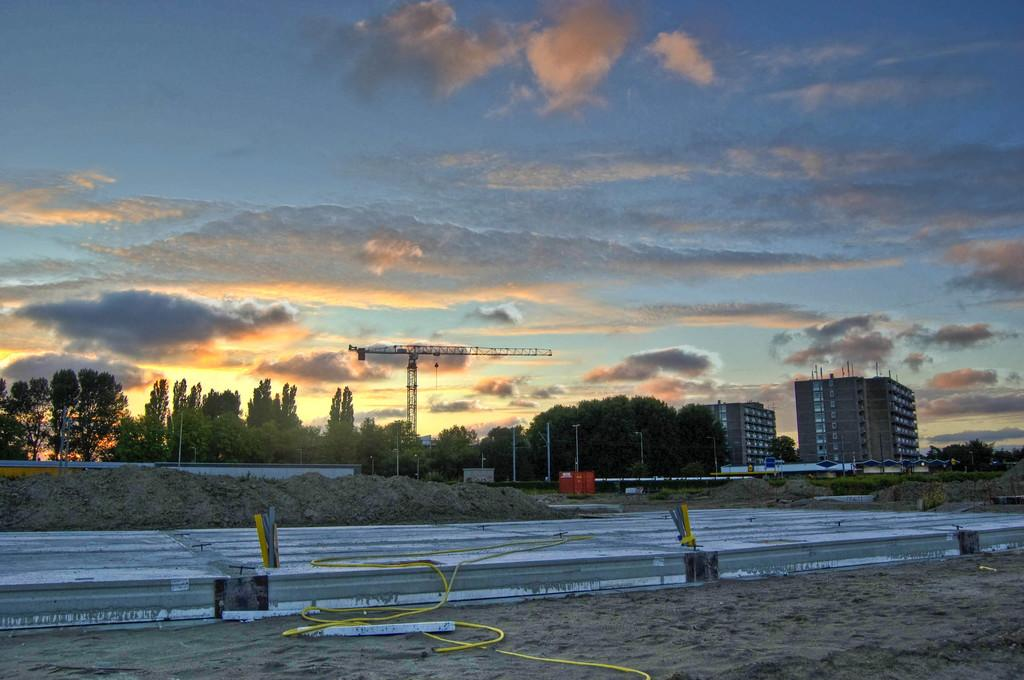What type of terrain is visible in the image? There is sand in the image. What object can be seen in the image that is related to water or drainage? There is a pipe in the image. What type of vegetation is present in the image? There are trees in the image. What type of structure is visible in the image? There is a building in the image. What part of the natural environment is visible in the image? The sky is visible in the image. What can be seen in the sky in the image? There are clouds in the sky. How many girls are playing with the truck in the image? There is no truck or girls present in the image. What type of insurance is being advertised on the building in the image? There is no insurance advertisement on the building in the image. 